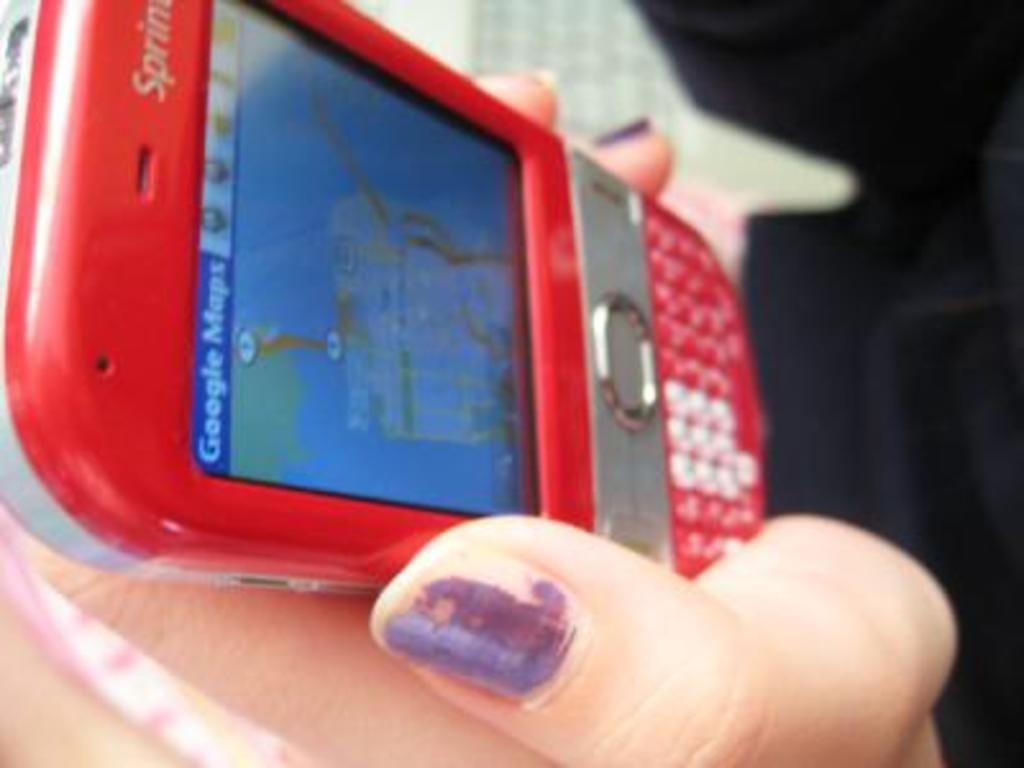<image>
Relay a brief, clear account of the picture shown. The app being run on the phone is Google Maps 